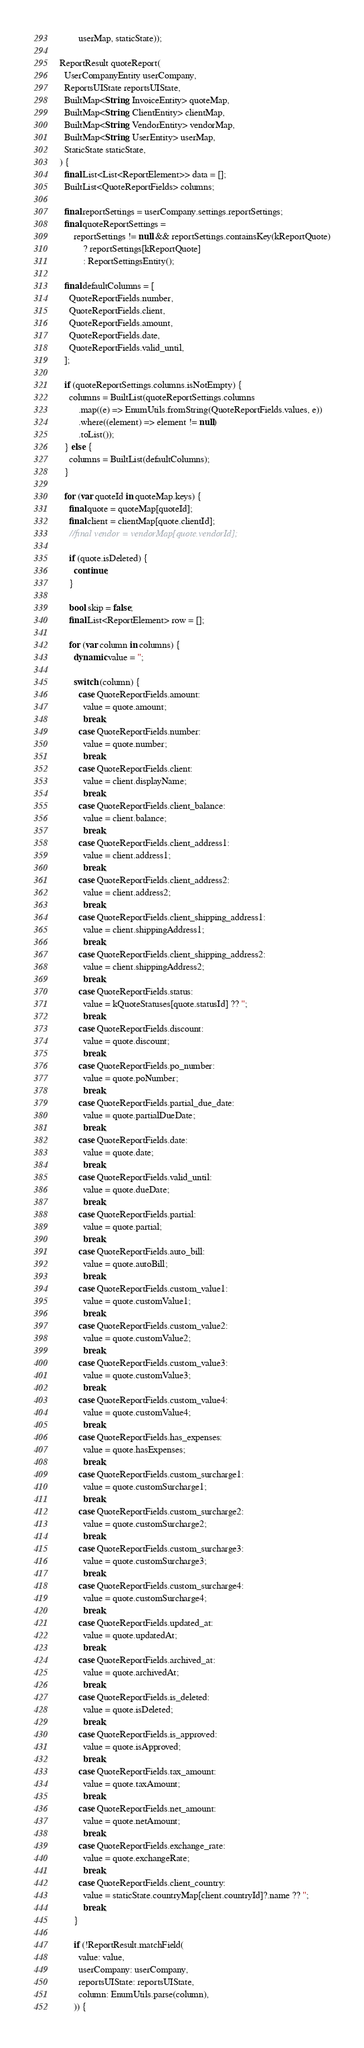Convert code to text. <code><loc_0><loc_0><loc_500><loc_500><_Dart_>        userMap, staticState));

ReportResult quoteReport(
  UserCompanyEntity userCompany,
  ReportsUIState reportsUIState,
  BuiltMap<String, InvoiceEntity> quoteMap,
  BuiltMap<String, ClientEntity> clientMap,
  BuiltMap<String, VendorEntity> vendorMap,
  BuiltMap<String, UserEntity> userMap,
  StaticState staticState,
) {
  final List<List<ReportElement>> data = [];
  BuiltList<QuoteReportFields> columns;

  final reportSettings = userCompany.settings.reportSettings;
  final quoteReportSettings =
      reportSettings != null && reportSettings.containsKey(kReportQuote)
          ? reportSettings[kReportQuote]
          : ReportSettingsEntity();

  final defaultColumns = [
    QuoteReportFields.number,
    QuoteReportFields.client,
    QuoteReportFields.amount,
    QuoteReportFields.date,
    QuoteReportFields.valid_until,
  ];

  if (quoteReportSettings.columns.isNotEmpty) {
    columns = BuiltList(quoteReportSettings.columns
        .map((e) => EnumUtils.fromString(QuoteReportFields.values, e))
        .where((element) => element != null)
        .toList());
  } else {
    columns = BuiltList(defaultColumns);
  }

  for (var quoteId in quoteMap.keys) {
    final quote = quoteMap[quoteId];
    final client = clientMap[quote.clientId];
    //final vendor = vendorMap[quote.vendorId];

    if (quote.isDeleted) {
      continue;
    }

    bool skip = false;
    final List<ReportElement> row = [];

    for (var column in columns) {
      dynamic value = '';

      switch (column) {
        case QuoteReportFields.amount:
          value = quote.amount;
          break;
        case QuoteReportFields.number:
          value = quote.number;
          break;
        case QuoteReportFields.client:
          value = client.displayName;
          break;
        case QuoteReportFields.client_balance:
          value = client.balance;
          break;
        case QuoteReportFields.client_address1:
          value = client.address1;
          break;
        case QuoteReportFields.client_address2:
          value = client.address2;
          break;
        case QuoteReportFields.client_shipping_address1:
          value = client.shippingAddress1;
          break;
        case QuoteReportFields.client_shipping_address2:
          value = client.shippingAddress2;
          break;
        case QuoteReportFields.status:
          value = kQuoteStatuses[quote.statusId] ?? '';
          break;
        case QuoteReportFields.discount:
          value = quote.discount;
          break;
        case QuoteReportFields.po_number:
          value = quote.poNumber;
          break;
        case QuoteReportFields.partial_due_date:
          value = quote.partialDueDate;
          break;
        case QuoteReportFields.date:
          value = quote.date;
          break;
        case QuoteReportFields.valid_until:
          value = quote.dueDate;
          break;
        case QuoteReportFields.partial:
          value = quote.partial;
          break;
        case QuoteReportFields.auto_bill:
          value = quote.autoBill;
          break;
        case QuoteReportFields.custom_value1:
          value = quote.customValue1;
          break;
        case QuoteReportFields.custom_value2:
          value = quote.customValue2;
          break;
        case QuoteReportFields.custom_value3:
          value = quote.customValue3;
          break;
        case QuoteReportFields.custom_value4:
          value = quote.customValue4;
          break;
        case QuoteReportFields.has_expenses:
          value = quote.hasExpenses;
          break;
        case QuoteReportFields.custom_surcharge1:
          value = quote.customSurcharge1;
          break;
        case QuoteReportFields.custom_surcharge2:
          value = quote.customSurcharge2;
          break;
        case QuoteReportFields.custom_surcharge3:
          value = quote.customSurcharge3;
          break;
        case QuoteReportFields.custom_surcharge4:
          value = quote.customSurcharge4;
          break;
        case QuoteReportFields.updated_at:
          value = quote.updatedAt;
          break;
        case QuoteReportFields.archived_at:
          value = quote.archivedAt;
          break;
        case QuoteReportFields.is_deleted:
          value = quote.isDeleted;
          break;
        case QuoteReportFields.is_approved:
          value = quote.isApproved;
          break;
        case QuoteReportFields.tax_amount:
          value = quote.taxAmount;
          break;
        case QuoteReportFields.net_amount:
          value = quote.netAmount;
          break;
        case QuoteReportFields.exchange_rate:
          value = quote.exchangeRate;
          break;
        case QuoteReportFields.client_country:
          value = staticState.countryMap[client.countryId]?.name ?? '';
          break;
      }

      if (!ReportResult.matchField(
        value: value,
        userCompany: userCompany,
        reportsUIState: reportsUIState,
        column: EnumUtils.parse(column),
      )) {</code> 